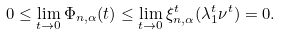<formula> <loc_0><loc_0><loc_500><loc_500>0 \leq \lim _ { t \to 0 } \Phi _ { n , \alpha } ( t ) \leq \lim _ { t \to 0 } \xi ^ { t } _ { n , \alpha } ( \lambda _ { 1 } ^ { t } \nu ^ { t } ) = 0 .</formula> 